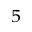<formula> <loc_0><loc_0><loc_500><loc_500>_ { 5 }</formula> 